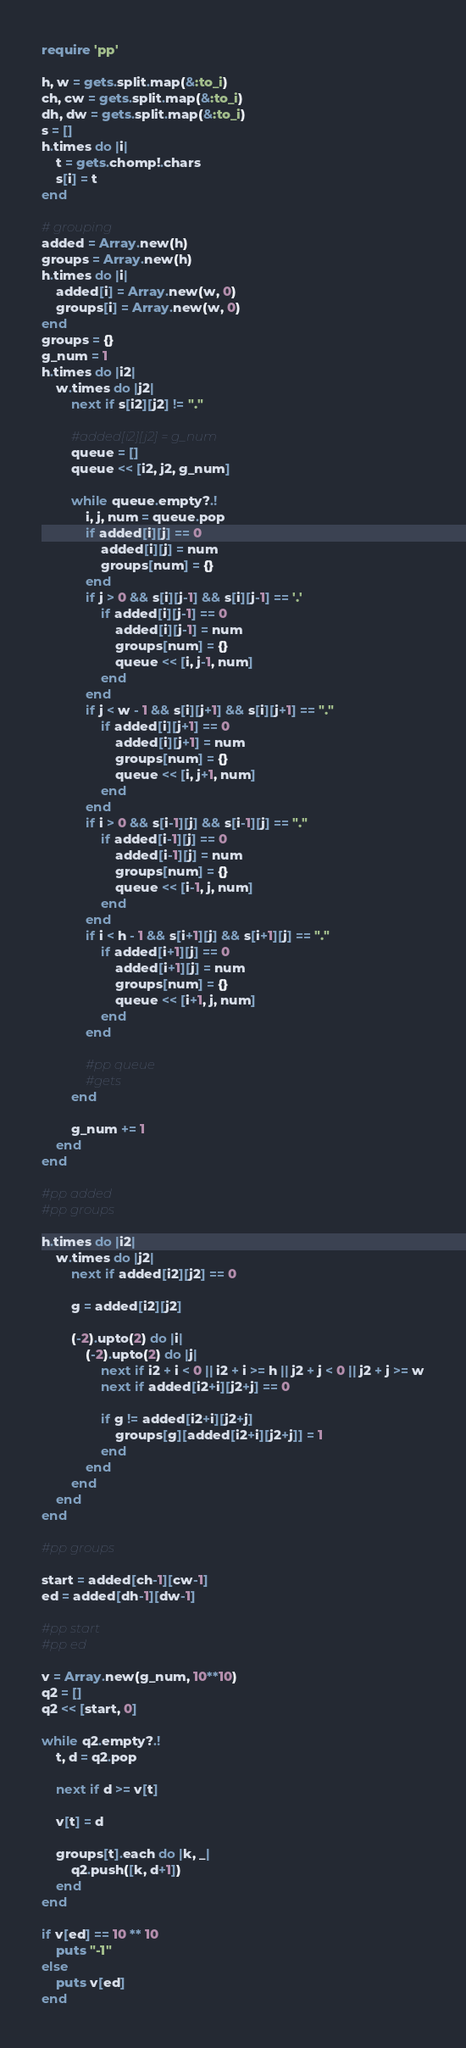<code> <loc_0><loc_0><loc_500><loc_500><_Ruby_>require 'pp'

h, w = gets.split.map(&:to_i)
ch, cw = gets.split.map(&:to_i)
dh, dw = gets.split.map(&:to_i)
s = []
h.times do |i|
    t = gets.chomp!.chars
    s[i] = t
end

# grouping
added = Array.new(h)
groups = Array.new(h)
h.times do |i|
    added[i] = Array.new(w, 0)
    groups[i] = Array.new(w, 0)
end
groups = {}
g_num = 1
h.times do |i2|
    w.times do |j2|
        next if s[i2][j2] != "."
        
        #added[i2][j2] = g_num
        queue = []
        queue << [i2, j2, g_num]

        while queue.empty?.!
            i, j, num = queue.pop
            if added[i][j] == 0
                added[i][j] = num
                groups[num] = {}
            end
            if j > 0 && s[i][j-1] && s[i][j-1] == '.'
                if added[i][j-1] == 0
                    added[i][j-1] = num
                    groups[num] = {}
                    queue << [i, j-1, num]
                end
            end
            if j < w - 1 && s[i][j+1] && s[i][j+1] == "."
                if added[i][j+1] == 0
                    added[i][j+1] = num
                    groups[num] = {}
                    queue << [i, j+1, num]
                end
            end
            if i > 0 && s[i-1][j] && s[i-1][j] == "."
                if added[i-1][j] == 0
                    added[i-1][j] = num
                    groups[num] = {}
                    queue << [i-1, j, num]
                end
            end
            if i < h - 1 && s[i+1][j] && s[i+1][j] == "."
                if added[i+1][j] == 0
                    added[i+1][j] = num
                    groups[num] = {}
                    queue << [i+1, j, num]
                end
            end

            #pp queue
            #gets
        end

        g_num += 1
    end
end

#pp added
#pp groups

h.times do |i2|
    w.times do |j2|
        next if added[i2][j2] == 0

        g = added[i2][j2]
    
        (-2).upto(2) do |i|
            (-2).upto(2) do |j|
                next if i2 + i < 0 || i2 + i >= h || j2 + j < 0 || j2 + j >= w
                next if added[i2+i][j2+j] == 0
                
                if g != added[i2+i][j2+j]
                    groups[g][added[i2+i][j2+j]] = 1
                end
            end
        end
    end
end

#pp groups

start = added[ch-1][cw-1]
ed = added[dh-1][dw-1]

#pp start
#pp ed

v = Array.new(g_num, 10**10)
q2 = []
q2 << [start, 0]

while q2.empty?.!
    t, d = q2.pop

    next if d >= v[t] 

    v[t] = d

    groups[t].each do |k, _|
        q2.push([k, d+1])
    end
end

if v[ed] == 10 ** 10
    puts "-1"
else
    puts v[ed]
end

</code> 